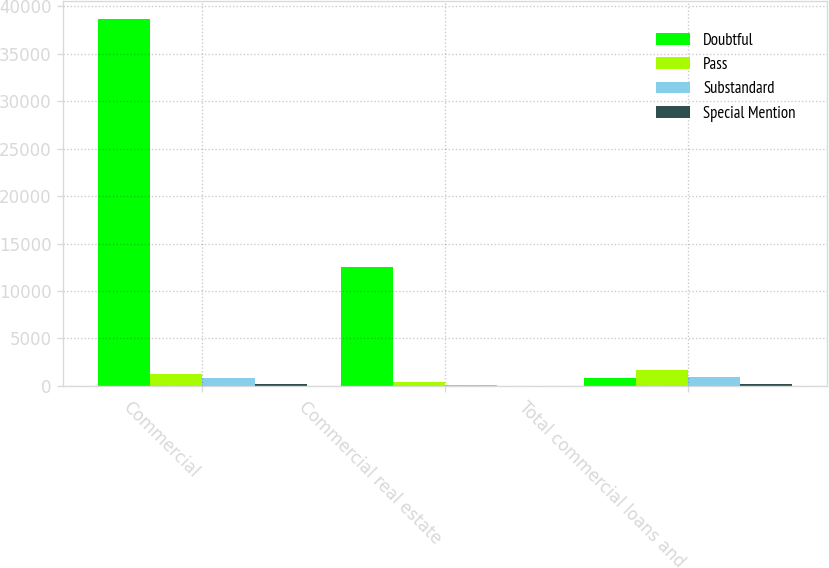Convert chart. <chart><loc_0><loc_0><loc_500><loc_500><stacked_bar_chart><ecel><fcel>Commercial<fcel>Commercial real estate<fcel>Total commercial loans and<nl><fcel>Doubtful<fcel>38600<fcel>12523<fcel>828<nl><fcel>Pass<fcel>1231<fcel>412<fcel>1682<nl><fcel>Substandard<fcel>828<fcel>82<fcel>951<nl><fcel>Special Mention<fcel>198<fcel>6<fcel>204<nl></chart> 